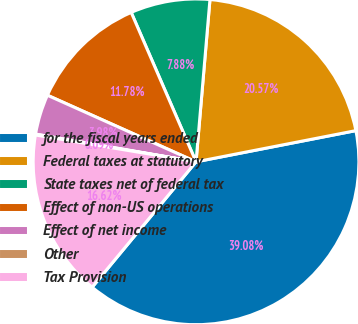Convert chart to OTSL. <chart><loc_0><loc_0><loc_500><loc_500><pie_chart><fcel>for the fiscal years ended<fcel>Federal taxes at statutory<fcel>State taxes net of federal tax<fcel>Effect of non-US operations<fcel>Effect of net income<fcel>Other<fcel>Tax Provision<nl><fcel>39.08%<fcel>20.57%<fcel>7.88%<fcel>11.78%<fcel>3.98%<fcel>0.09%<fcel>16.62%<nl></chart> 